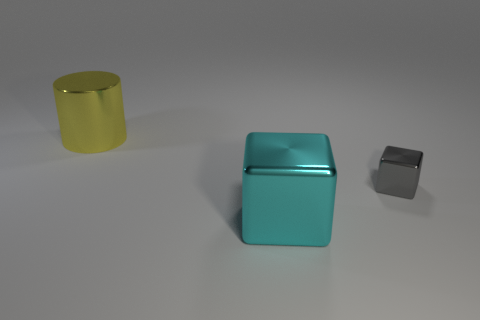Add 1 purple rubber things. How many objects exist? 4 Subtract all blocks. How many objects are left? 1 Add 2 small metal blocks. How many small metal blocks exist? 3 Subtract 1 yellow cylinders. How many objects are left? 2 Subtract all tiny blue rubber cylinders. Subtract all cylinders. How many objects are left? 2 Add 2 large cubes. How many large cubes are left? 3 